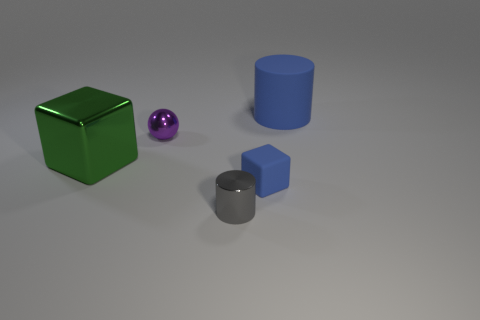Are there any large matte things?
Your answer should be compact. Yes. There is a small shiny thing that is on the left side of the gray object; what color is it?
Your answer should be compact. Purple. What material is the gray thing that is the same size as the purple metallic sphere?
Provide a short and direct response. Metal. What number of other objects are the same material as the green block?
Ensure brevity in your answer.  2. What is the color of the object that is behind the big metal thing and to the left of the blue matte cylinder?
Give a very brief answer. Purple. How many objects are big blue things behind the big shiny block or cubes?
Provide a succinct answer. 3. What number of other things are the same color as the shiny ball?
Ensure brevity in your answer.  0. Are there an equal number of tiny balls behind the big blue matte cylinder and small purple metallic balls?
Your response must be concise. No. What number of shiny things are in front of the large thing that is on the left side of the object behind the purple shiny ball?
Offer a terse response. 1. Do the green block and the metal object that is on the right side of the purple sphere have the same size?
Offer a terse response. No. 